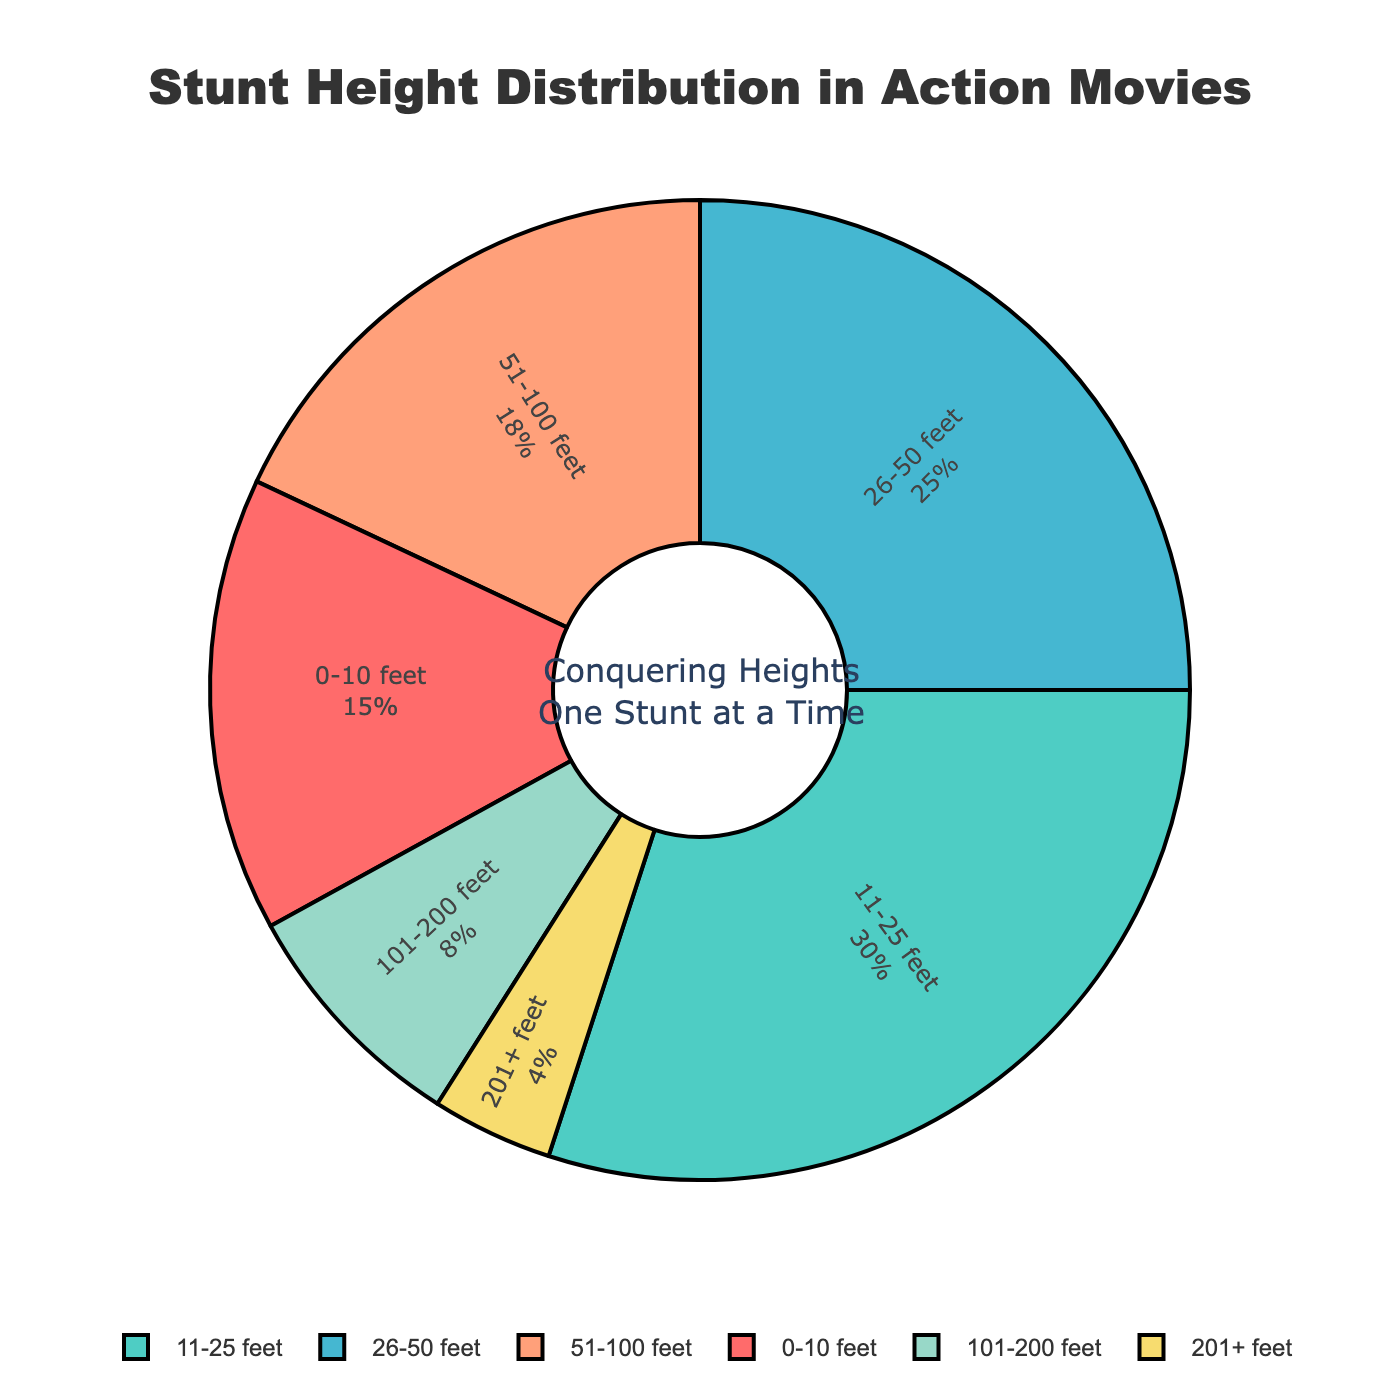What's the height range with the highest percentage of stunts performed? Look at the pie chart sections and note which section has the largest area. The section with the label "11-25 feet" has the largest area, corresponding to 30%.
Answer: 11-25 feet Which height range has the smallest percentage of stunts performed? Look at the pie chart sections and note which has the smallest area. The "201+ feet" section is the smallest, corresponding to 4%.
Answer: 201+ feet What is the combined percentage of stunts performed between 26-50 feet and 51-100 feet? Find the percentages for both ranges: 26-50 feet (25%) and 51-100 feet (18%). Add these percentages together: 25% + 18% = 43%.
Answer: 43% Is the percentage of stunts performed under 25 feet greater than those performed over 50 feet? Find the percentages for stunts under 25 feet: 0-10 feet (15%) + 11-25 feet (30%) = 45%. For stunts over 50 feet: 51-100 feet (18%) + 101-200 feet (8%) + 201+ feet (4%) = 30%. Compare the two, 45% (under 25 feet) is greater than 30% (over 50 feet).
Answer: Yes What are the two closest percentages? Evaluate the percentages: 15%, 30%, 25%, 18%, 8%, and 4%. The two closest percentages are 18% for 51-100 feet and 15% for 0-10 feet, with a difference of 3%.
Answer: 15% and 18% Which height range’s proportion of stunts is closest to the combined proportion of 0-10 feet and 201+ feet? Combine the percentages for 0-10 feet (15%) and 201+ feet (4%): 15% + 4% = 19%. The range that is closest to 19% is 51-100 feet at 18%.
Answer: 51-100 feet Compare the proportions of stunts performed at 101-200 feet to 26-50 feet. Which is greater and by how much? Percentages: 101-200 feet (8%) and 26-50 feet (25%). Subtract to find the difference: 25% - 8% = 17%. The 26-50 feet range is greater by 17%.
Answer: 26-50 feet is greater by 17% What percentage of stunts are performed at heights above 100 feet? Find the sums of the percentages for stunts above 100 feet: 101-200 feet (8%) + 201+ feet (4%) = 12%.
Answer: 12% 